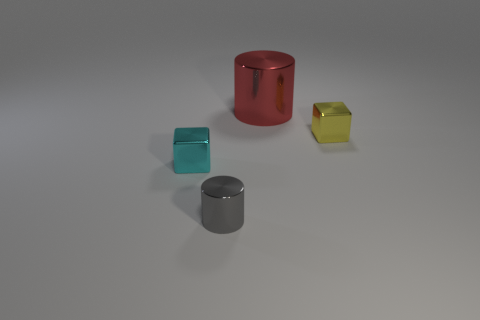Is the color of the large shiny cylinder the same as the tiny shiny cylinder?
Provide a succinct answer. No. There is a metallic thing that is to the left of the small gray metal object that is in front of the metallic block that is to the right of the large thing; what is its shape?
Ensure brevity in your answer.  Cube. Is there a yellow thing that has the same size as the cyan thing?
Offer a terse response. Yes. What is the size of the yellow block?
Your answer should be very brief. Small. What number of gray cylinders have the same size as the red thing?
Provide a short and direct response. 0. Are there fewer large red cylinders behind the large shiny cylinder than small gray cylinders that are behind the tiny gray cylinder?
Your answer should be very brief. No. What is the size of the metal block that is on the left side of the thing behind the cube that is behind the tiny cyan metal block?
Give a very brief answer. Small. What is the size of the metallic object that is both behind the tiny gray metal cylinder and to the left of the big cylinder?
Give a very brief answer. Small. The red metallic object that is to the left of the small shiny object behind the small cyan metallic object is what shape?
Provide a short and direct response. Cylinder. Is there any other thing that is the same color as the tiny metal cylinder?
Provide a succinct answer. No. 